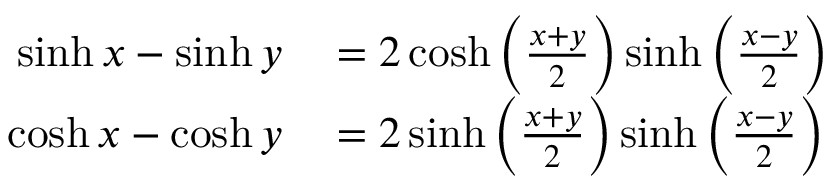Convert formula to latex. <formula><loc_0><loc_0><loc_500><loc_500>\begin{array} { r l } { \sinh x - \sinh y } & = 2 \cosh \left ( { \frac { x + y } { 2 } } \right ) \sinh \left ( { \frac { x - y } { 2 } } \right ) } \\ { \cosh x - \cosh y } & = 2 \sinh \left ( { \frac { x + y } { 2 } } \right ) \sinh \left ( { \frac { x - y } { 2 } } \right ) } \end{array}</formula> 